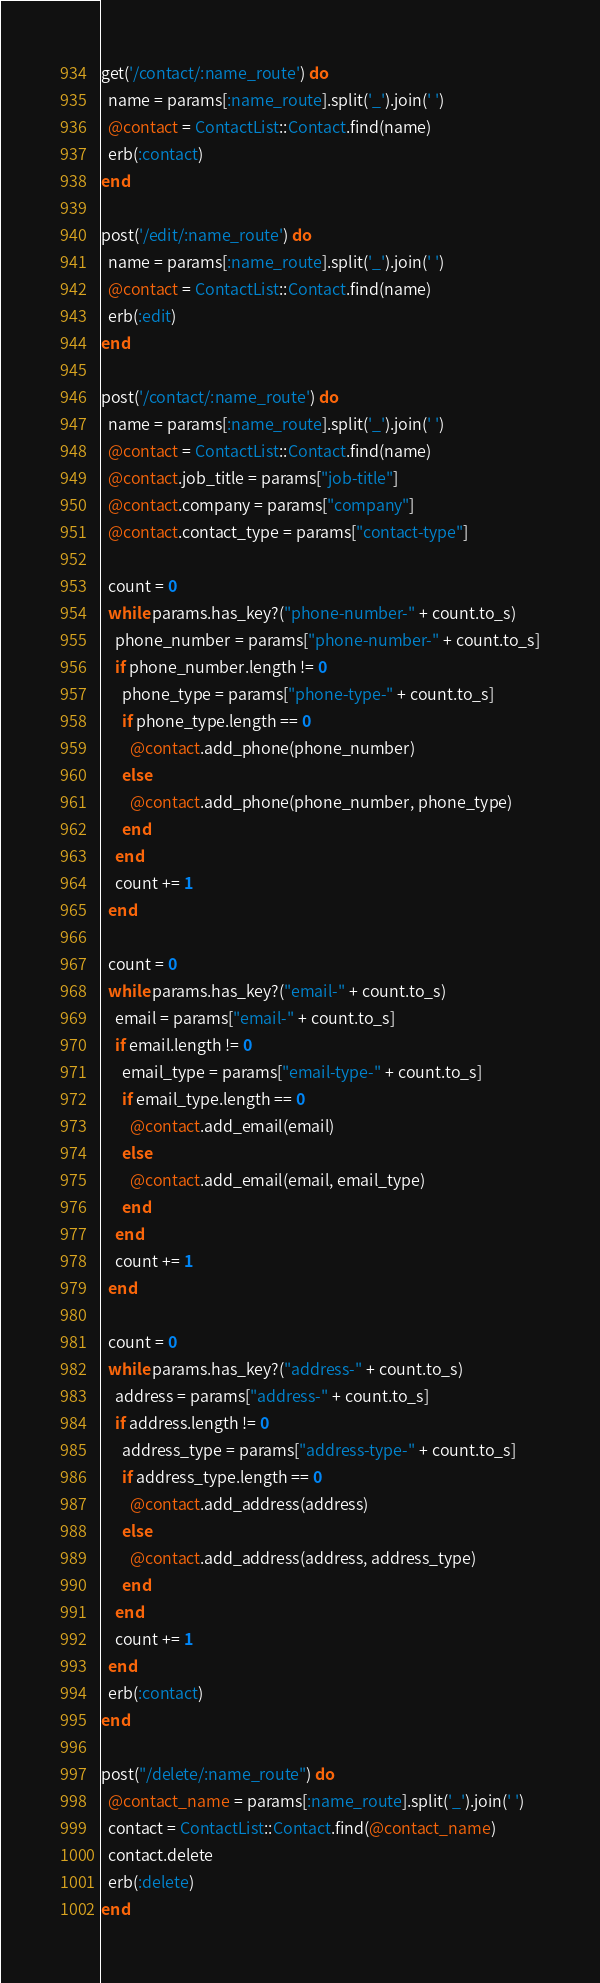Convert code to text. <code><loc_0><loc_0><loc_500><loc_500><_Ruby_>get('/contact/:name_route') do
  name = params[:name_route].split('_').join(' ')
  @contact = ContactList::Contact.find(name)
  erb(:contact)
end

post('/edit/:name_route') do
  name = params[:name_route].split('_').join(' ')
  @contact = ContactList::Contact.find(name)
  erb(:edit)
end

post('/contact/:name_route') do
  name = params[:name_route].split('_').join(' ')
  @contact = ContactList::Contact.find(name)
  @contact.job_title = params["job-title"]
  @contact.company = params["company"]
  @contact.contact_type = params["contact-type"]

  count = 0
  while params.has_key?("phone-number-" + count.to_s)
    phone_number = params["phone-number-" + count.to_s]
    if phone_number.length != 0
      phone_type = params["phone-type-" + count.to_s]
      if phone_type.length == 0
        @contact.add_phone(phone_number)
      else
        @contact.add_phone(phone_number, phone_type)
      end
    end
    count += 1
  end

  count = 0
  while params.has_key?("email-" + count.to_s)
    email = params["email-" + count.to_s]
    if email.length != 0
      email_type = params["email-type-" + count.to_s]
      if email_type.length == 0
        @contact.add_email(email)
      else
        @contact.add_email(email, email_type)
      end
    end
    count += 1
  end

  count = 0
  while params.has_key?("address-" + count.to_s)
    address = params["address-" + count.to_s]
    if address.length != 0
      address_type = params["address-type-" + count.to_s]
      if address_type.length == 0
        @contact.add_address(address)
      else
        @contact.add_address(address, address_type)
      end
    end
    count += 1
  end
  erb(:contact)
end

post("/delete/:name_route") do
  @contact_name = params[:name_route].split('_').join(' ')
  contact = ContactList::Contact.find(@contact_name)
  contact.delete
  erb(:delete)
end
</code> 